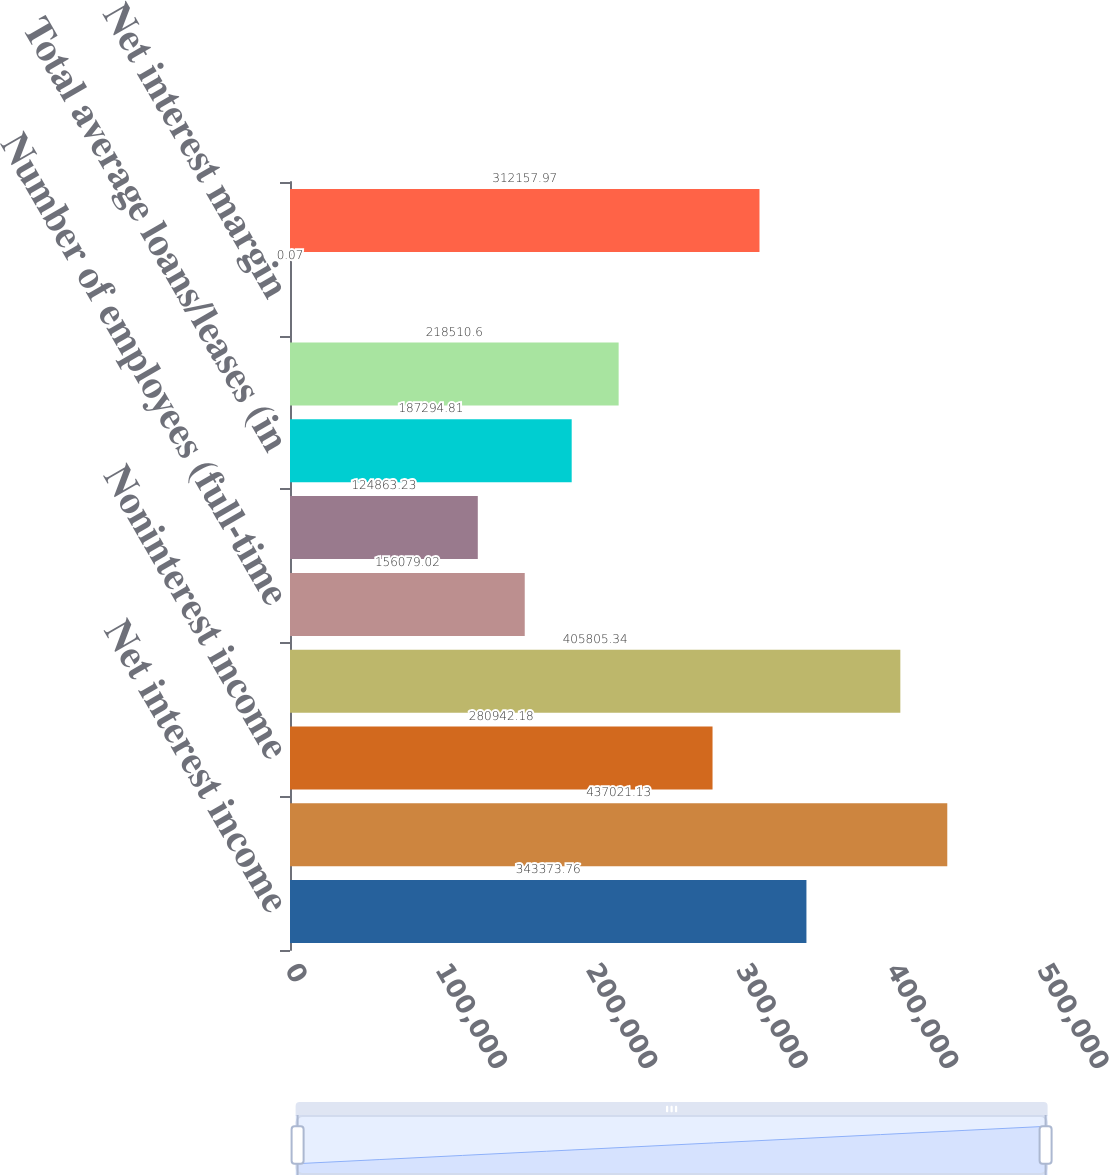Convert chart. <chart><loc_0><loc_0><loc_500><loc_500><bar_chart><fcel>Net interest income<fcel>Provision for credit losses<fcel>Noninterest income<fcel>Noninterest expense<fcel>Number of employees (full-time<fcel>Total average assets (in<fcel>Total average loans/leases (in<fcel>Total average deposits (in<fcel>Net interest margin<fcel>NCOs<nl><fcel>343374<fcel>437021<fcel>280942<fcel>405805<fcel>156079<fcel>124863<fcel>187295<fcel>218511<fcel>0.07<fcel>312158<nl></chart> 